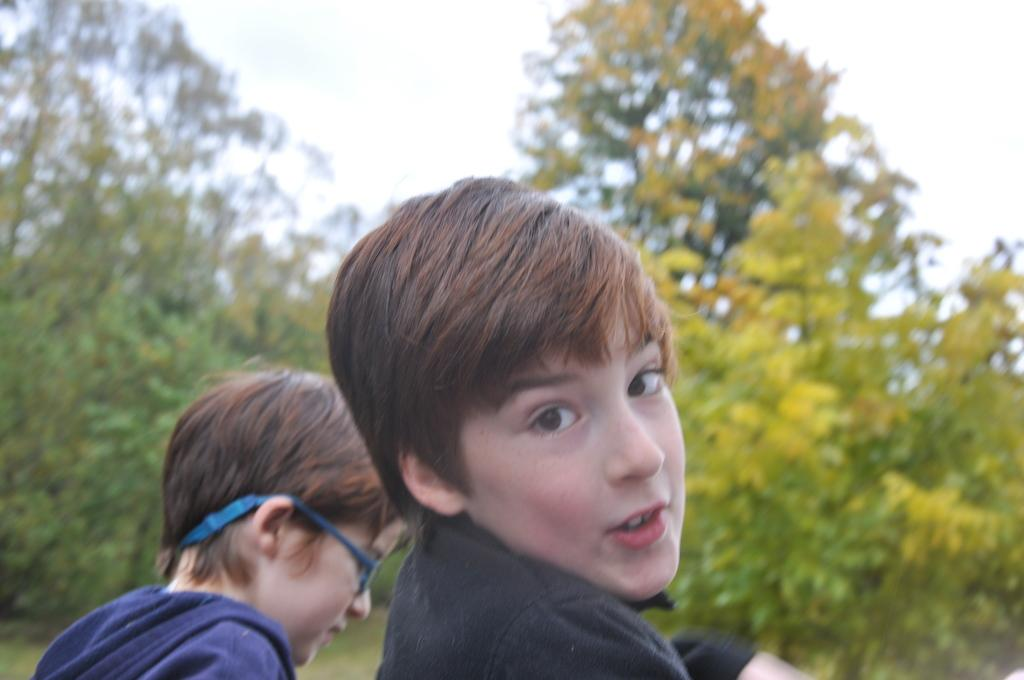What are the boys wearing in the image? There is a boy wearing a black dress and another boy wearing a blue dress in the image. Can you describe any additional features of the boy with the blue dress? The boy with the blue dress is wearing blue spectacles. What can be seen in the background of the image? There are trees and the sky visible in the background of the image. How many girls are present in the image? There are no girls present in the image; it features two boys. What type of tooth is visible in the image? There is no tooth visible in the image. 